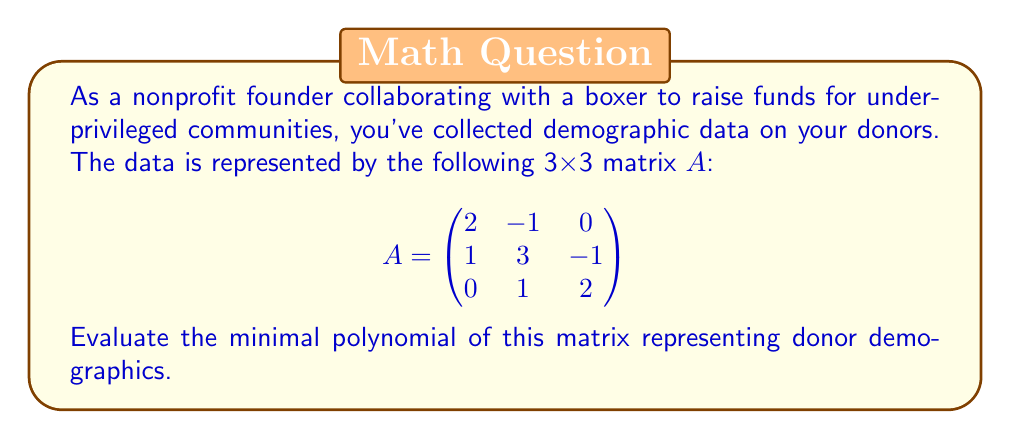Teach me how to tackle this problem. To find the minimal polynomial of matrix A, we'll follow these steps:

1) First, calculate the characteristic polynomial:
   $$\det(A - \lambda I) = \begin{vmatrix}
   2-\lambda & -1 & 0 \\
   1 & 3-\lambda & -1 \\
   0 & 1 & 2-\lambda
   \end{vmatrix}$$

   $$(2-\lambda)((3-\lambda)(2-\lambda) - 1) + (-1)(1(2-\lambda) - 0) = 0$$
   
   $$\lambda^3 - 7\lambda^2 + 16\lambda - 12 = 0$$

2) The characteristic polynomial is $p(\lambda) = \lambda^3 - 7\lambda^2 + 16\lambda - 12$.

3) Next, we need to check if $p(A) = 0$:

   $$p(A) = A^3 - 7A^2 + 16A - 12I$$

   Calculating $A^2$ and $A^3$:
   
   $$A^2 = \begin{pmatrix}
   3 & -5 & 1 \\
   3 & 8 & -5 \\
   1 & 5 & 3
   \end{pmatrix}$$

   $$A^3 = \begin{pmatrix}
   1 & -13 & 7 \\
   5 & 19 & -17 \\
   3 & 13 & 1
   \end{pmatrix}$$

   Substituting into $p(A)$:

   $$p(A) = \begin{pmatrix}
   1 & -13 & 7 \\
   5 & 19 & -17 \\
   3 & 13 & 1
   \end{pmatrix} - 7\begin{pmatrix}
   3 & -5 & 1 \\
   3 & 8 & -5 \\
   1 & 5 & 3
   \end{pmatrix} + 16\begin{pmatrix}
   2 & -1 & 0 \\
   1 & 3 & -1 \\
   0 & 1 & 2
   \end{pmatrix} - 12\begin{pmatrix}
   1 & 0 & 0 \\
   0 & 1 & 0 \\
   0 & 0 & 1
   \end{pmatrix} = \begin{pmatrix}
   0 & 0 & 0 \\
   0 & 0 & 0 \\
   0 & 0 & 0
   \end{pmatrix}$$

4) Since $p(A) = 0$, and $p(\lambda)$ is of degree 3 (which is the size of the matrix), the characteristic polynomial is also the minimal polynomial.

Therefore, the minimal polynomial of matrix A is $\lambda^3 - 7\lambda^2 + 16\lambda - 12$.
Answer: $\lambda^3 - 7\lambda^2 + 16\lambda - 12$ 